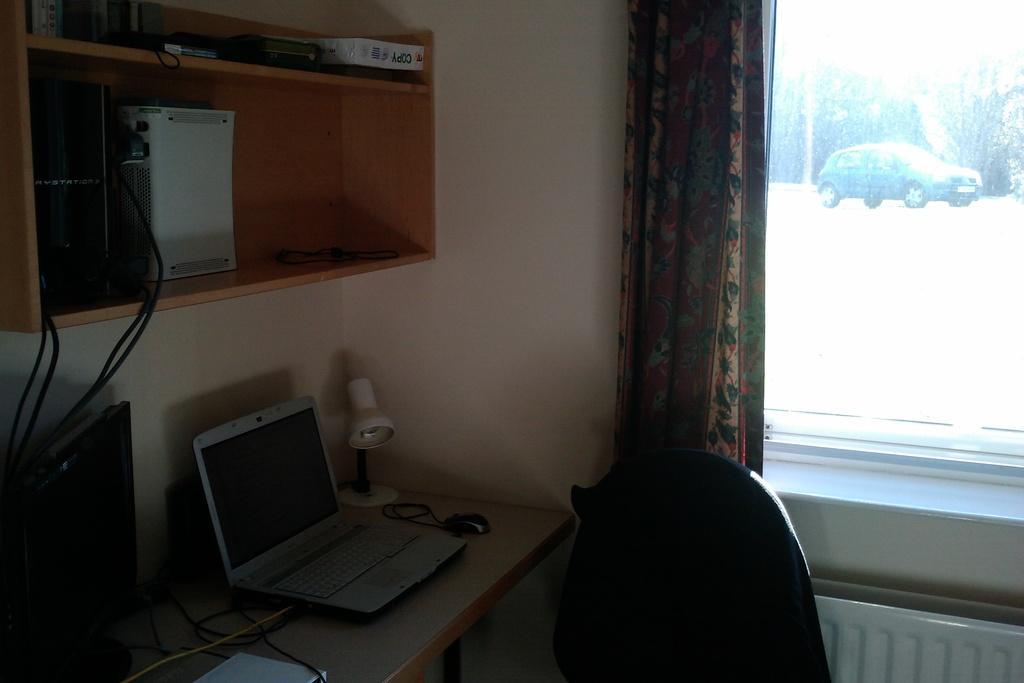Describe this image in one or two sentences. This is an inside view of a room. There is table and chair. On the table there is a laptop, a mouse, some cable wires, monitor and a table lamp. Just above the table there is cupboard in which there are some files and electronic devices. Behind the chair there is a curtain to the window. In the background there is a car and trees. 